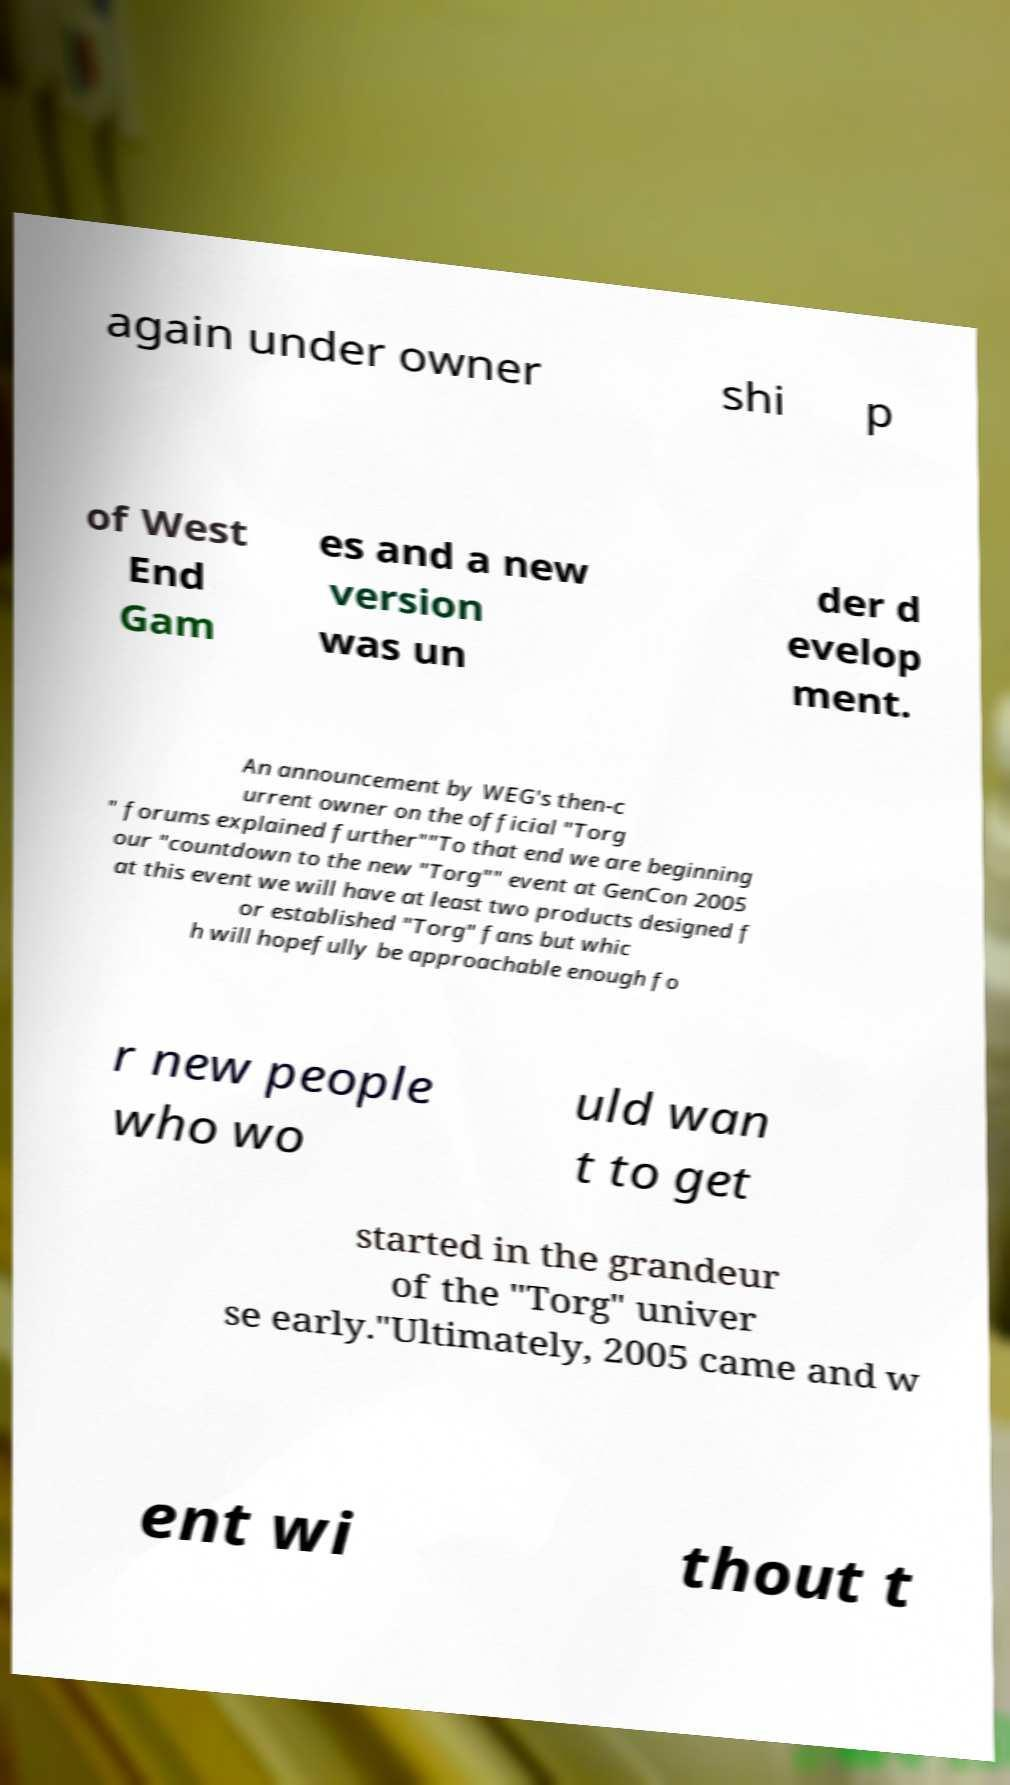What messages or text are displayed in this image? I need them in a readable, typed format. again under owner shi p of West End Gam es and a new version was un der d evelop ment. An announcement by WEG's then-c urrent owner on the official "Torg " forums explained further""To that end we are beginning our "countdown to the new "Torg"" event at GenCon 2005 at this event we will have at least two products designed f or established "Torg" fans but whic h will hopefully be approachable enough fo r new people who wo uld wan t to get started in the grandeur of the "Torg" univer se early."Ultimately, 2005 came and w ent wi thout t 